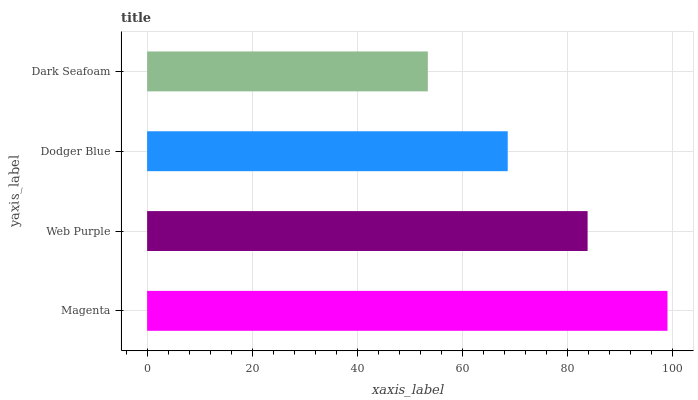Is Dark Seafoam the minimum?
Answer yes or no. Yes. Is Magenta the maximum?
Answer yes or no. Yes. Is Web Purple the minimum?
Answer yes or no. No. Is Web Purple the maximum?
Answer yes or no. No. Is Magenta greater than Web Purple?
Answer yes or no. Yes. Is Web Purple less than Magenta?
Answer yes or no. Yes. Is Web Purple greater than Magenta?
Answer yes or no. No. Is Magenta less than Web Purple?
Answer yes or no. No. Is Web Purple the high median?
Answer yes or no. Yes. Is Dodger Blue the low median?
Answer yes or no. Yes. Is Magenta the high median?
Answer yes or no. No. Is Magenta the low median?
Answer yes or no. No. 